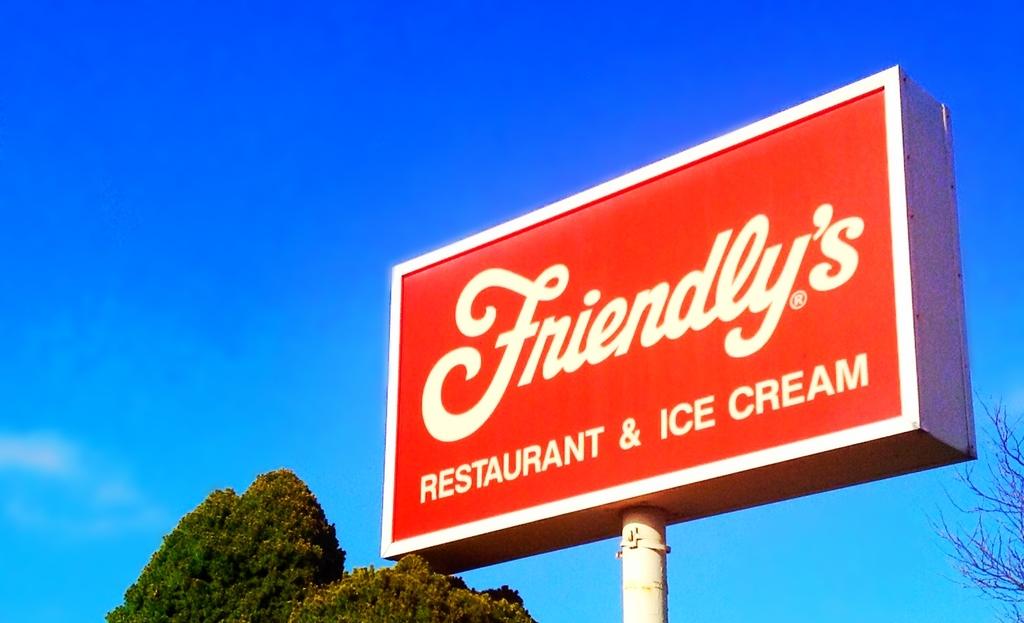What type of desert does the restaurant serve?
Ensure brevity in your answer.  Ice cream. What is the name of the place?
Make the answer very short. Friendly's. 